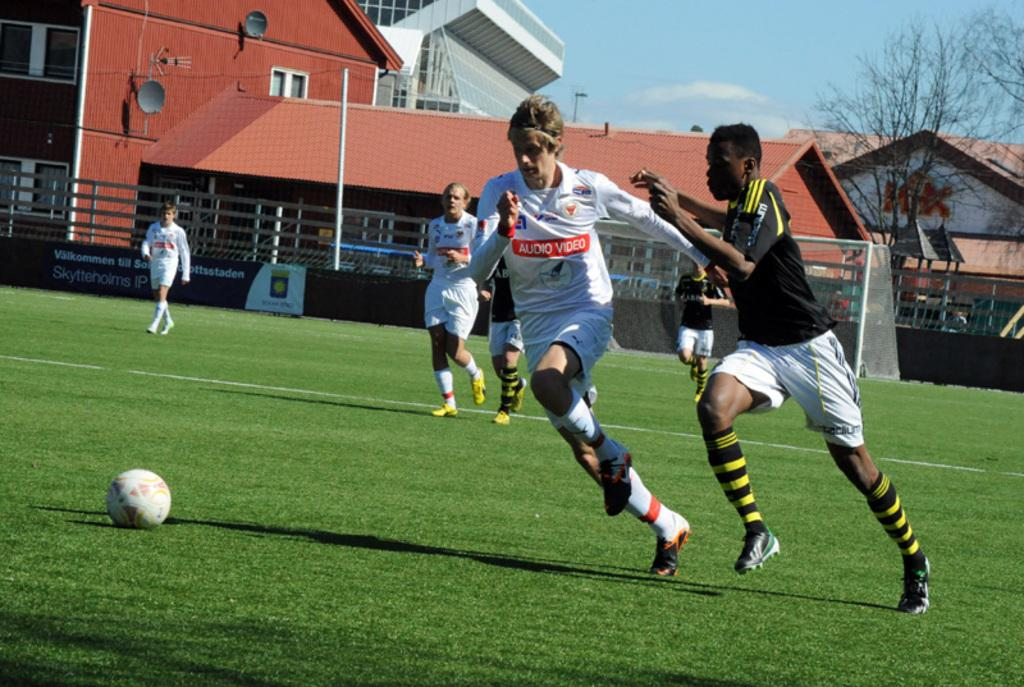<image>
Relay a brief, clear account of the picture shown. A soccer player with the words "audio video" runs after the ball. 